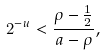<formula> <loc_0><loc_0><loc_500><loc_500>2 ^ { - u } < \frac { \rho - \frac { 1 } { 2 } } { a - \rho } ,</formula> 